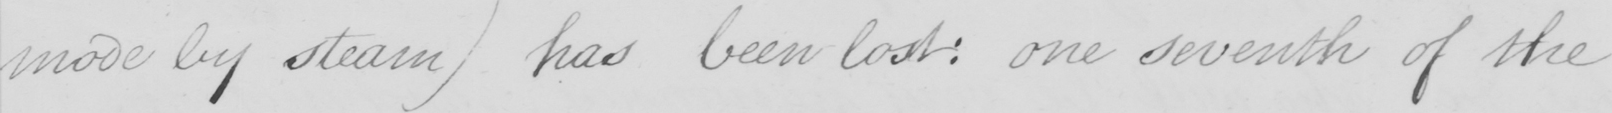Transcribe the text shown in this historical manuscript line. mode by steam )  has been lost :  one seventh of the 